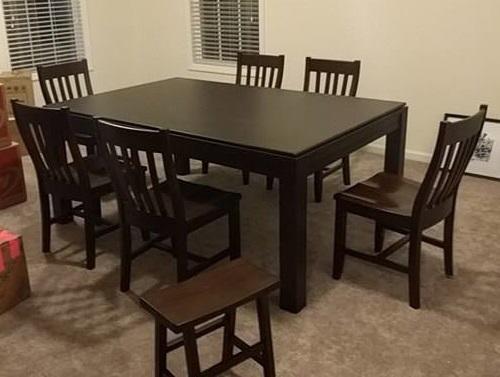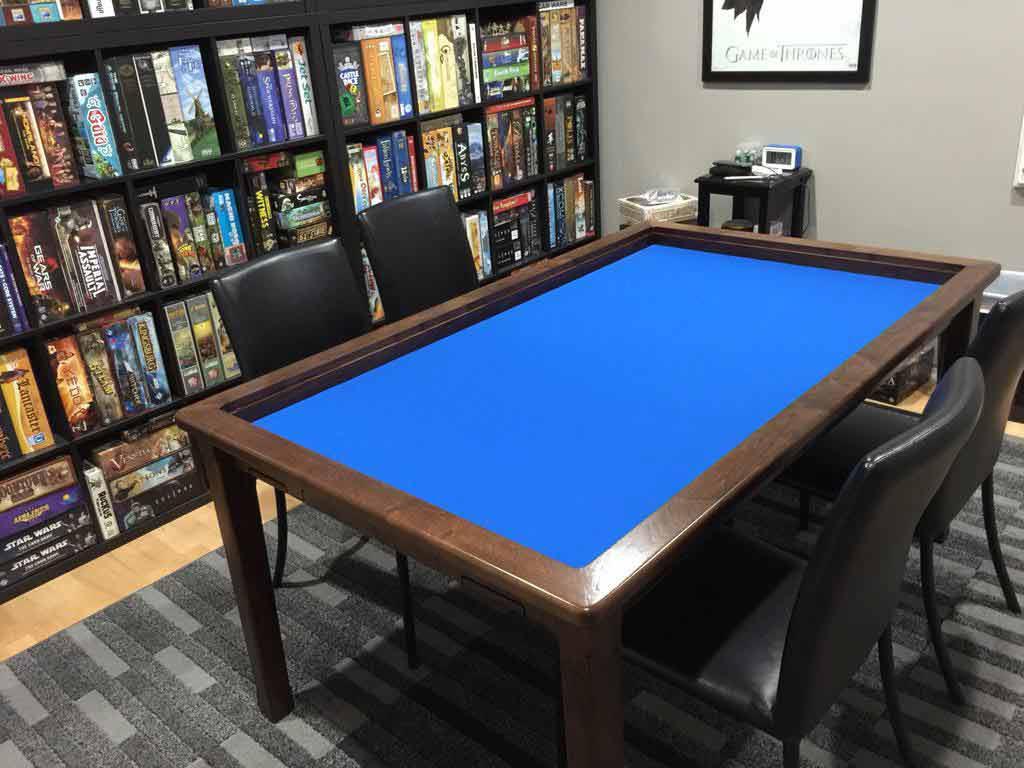The first image is the image on the left, the second image is the image on the right. Analyze the images presented: Is the assertion "An image shows a rectangular table with wood border, charcoal center, and no chairs." valid? Answer yes or no. No. The first image is the image on the left, the second image is the image on the right. For the images shown, is this caption "In one image, a rectangular table has chairs at each side and at each end." true? Answer yes or no. Yes. 